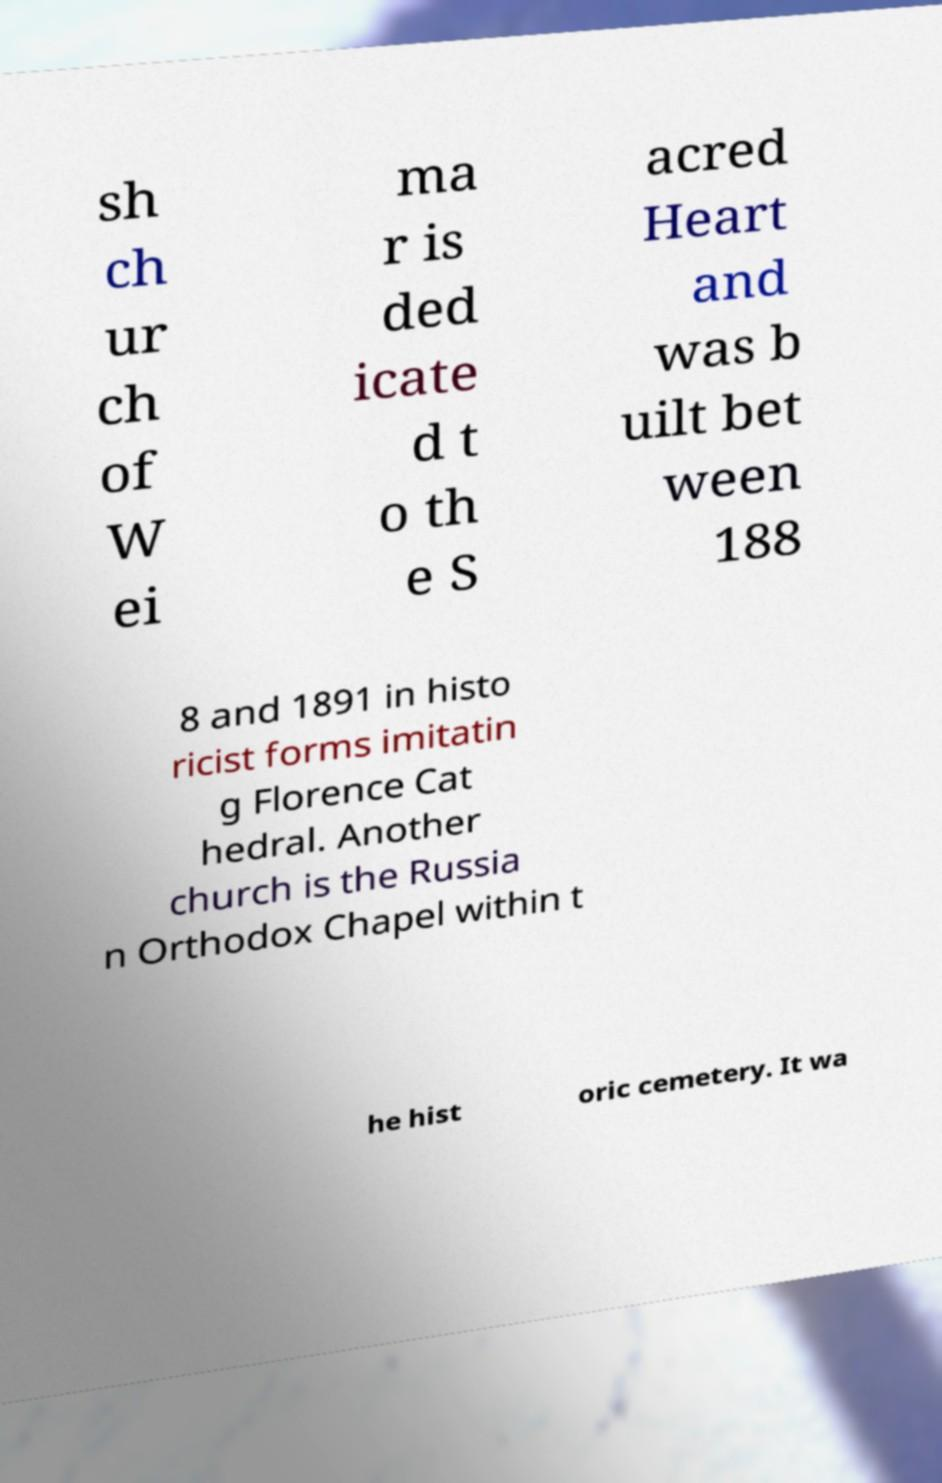What messages or text are displayed in this image? I need them in a readable, typed format. sh ch ur ch of W ei ma r is ded icate d t o th e S acred Heart and was b uilt bet ween 188 8 and 1891 in histo ricist forms imitatin g Florence Cat hedral. Another church is the Russia n Orthodox Chapel within t he hist oric cemetery. It wa 